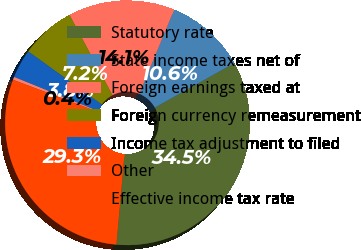<chart> <loc_0><loc_0><loc_500><loc_500><pie_chart><fcel>Statutory rate<fcel>State income taxes net of<fcel>Foreign earnings taxed at<fcel>Foreign currency remeasurement<fcel>Income tax adjustment to filed<fcel>Other<fcel>Effective income tax rate<nl><fcel>34.55%<fcel>10.64%<fcel>14.06%<fcel>7.23%<fcel>3.81%<fcel>0.39%<fcel>29.32%<nl></chart> 